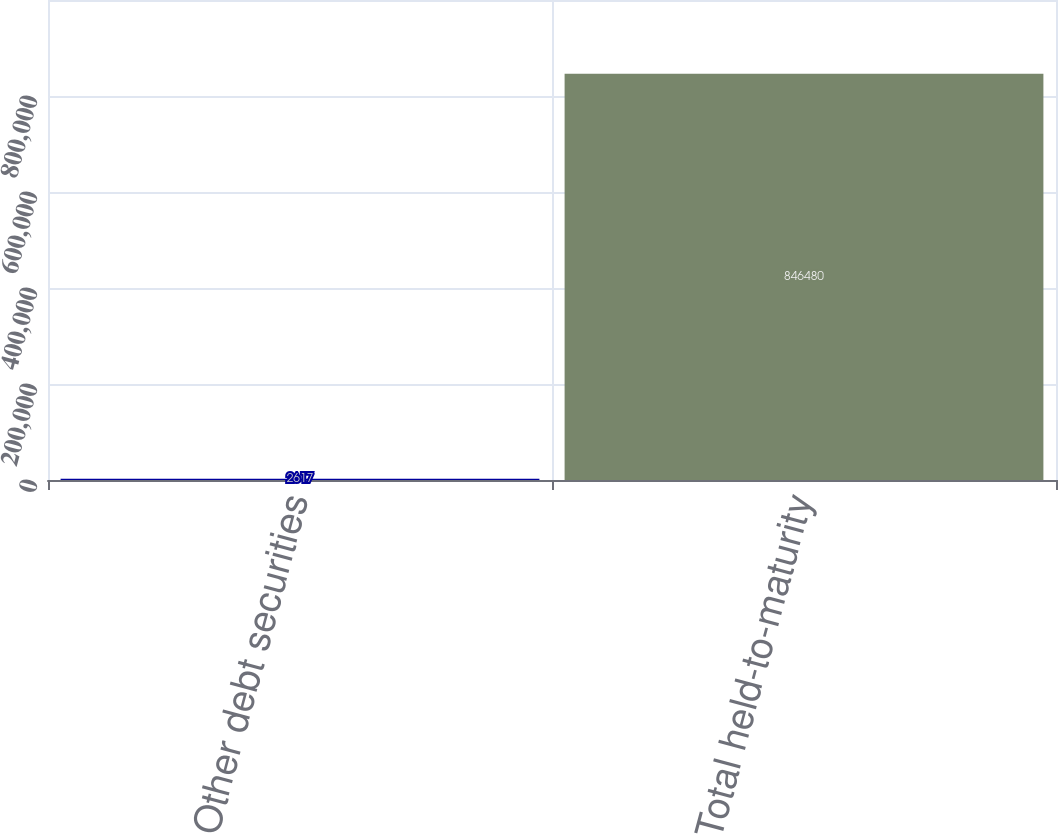Convert chart. <chart><loc_0><loc_0><loc_500><loc_500><bar_chart><fcel>Other debt securities<fcel>Total held-to-maturity<nl><fcel>2617<fcel>846480<nl></chart> 